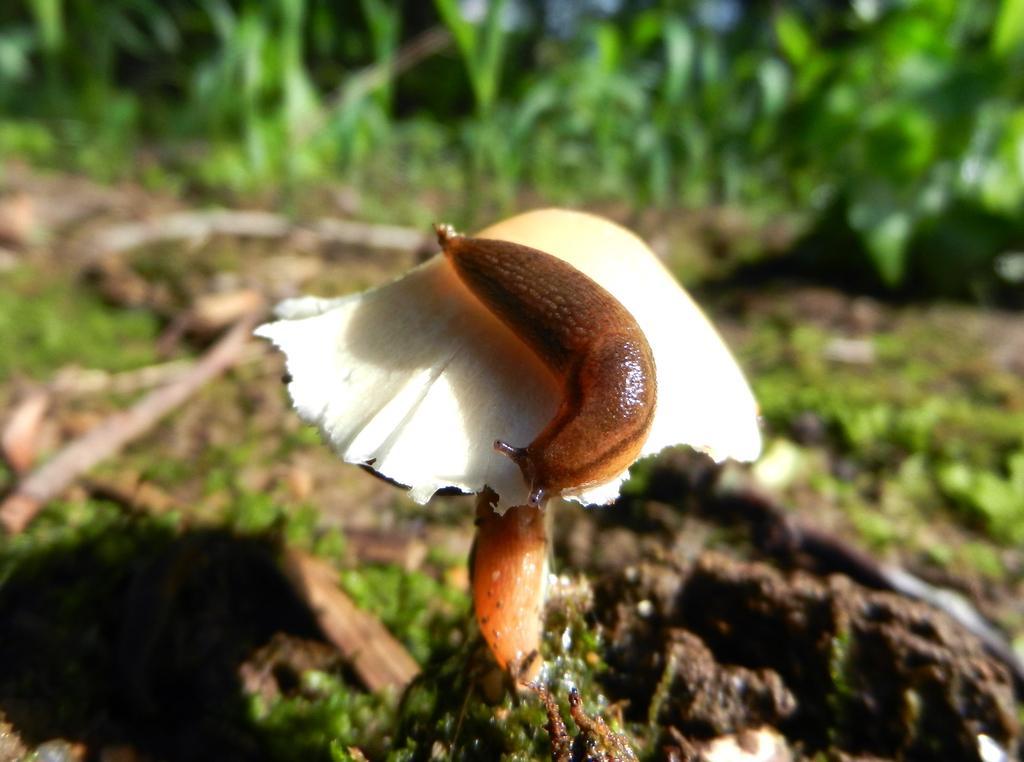Describe this image in one or two sentences. In this image an insect is sitting on a mushroom. There are many plants at the top most of the image. 